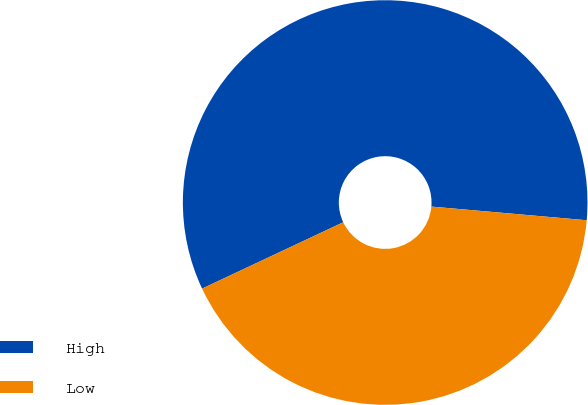Convert chart. <chart><loc_0><loc_0><loc_500><loc_500><pie_chart><fcel>High<fcel>Low<nl><fcel>58.39%<fcel>41.61%<nl></chart> 